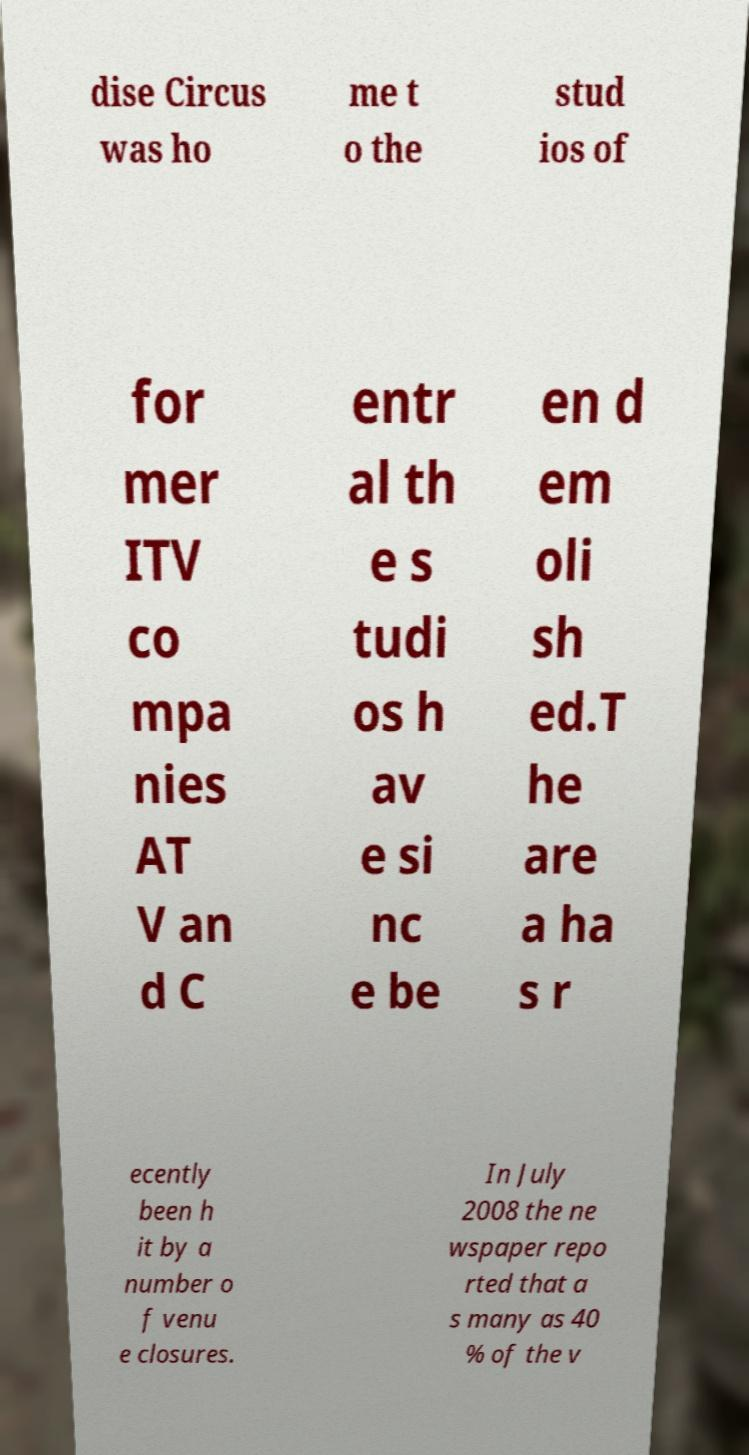Can you accurately transcribe the text from the provided image for me? dise Circus was ho me t o the stud ios of for mer ITV co mpa nies AT V an d C entr al th e s tudi os h av e si nc e be en d em oli sh ed.T he are a ha s r ecently been h it by a number o f venu e closures. In July 2008 the ne wspaper repo rted that a s many as 40 % of the v 